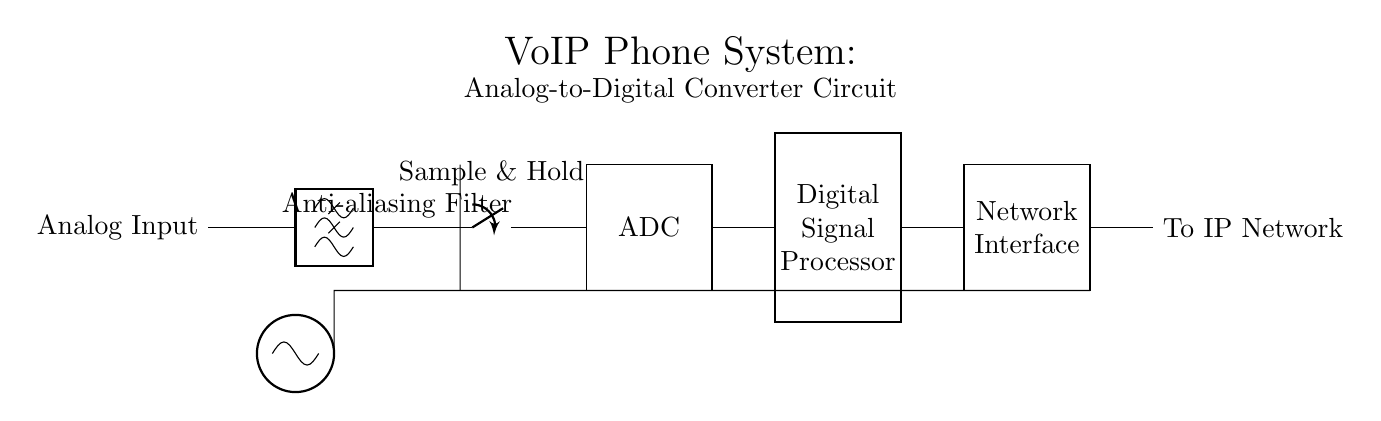What is the function of the anti-aliasing filter? The anti-aliasing filter smooths the analog input signal to prevent frequency components above the Nyquist frequency from causing distortion during the sampling process.
Answer: Smooths input What component follows the sample and hold? The component that follows the sample and hold is the ADC, which converts the analog signals into digital signals.
Answer: ADC How many main stages are in this circuit diagram? The circuit diagram has four main stages: the anti-aliasing filter, sample and hold, ADC, and digital signal processor.
Answer: Four What does the network interface connect to? The network interface connects to the IP network, enabling communication of the digitized signals over the internet.
Answer: IP network What is the role of the digital signal processor? The digital signal processor processes the digital signals to improve call quality and ensure efficient transmission.
Answer: Processes signals What is the purpose of the clock in this circuit? The clock provides timing signals necessary to synchronize the sampling and processing of the analog signals throughout the circuit.
Answer: Synchronization What type of filter is used in this circuit? This circuit uses a lowpass filter as an anti-aliasing filter to allow lower frequencies to pass while attenuating higher frequencies.
Answer: Lowpass filter 